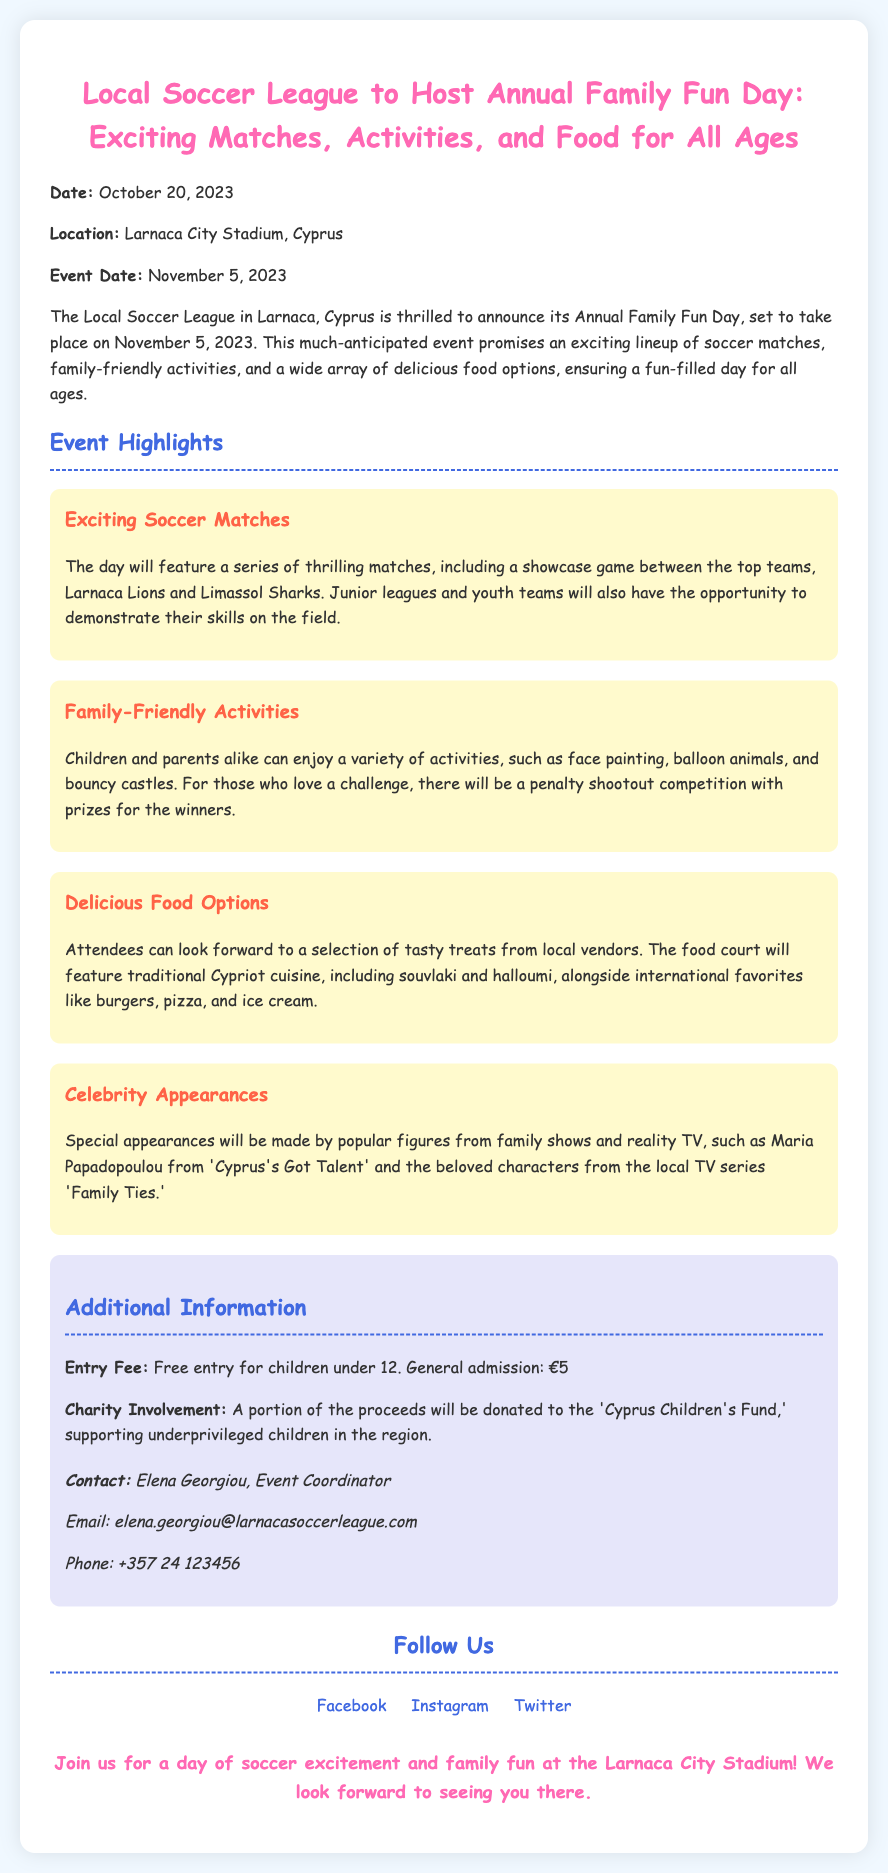What is the date of the event? The event is scheduled for November 5, 2023, as mentioned in the document.
Answer: November 5, 2023 Where is the Family Fun Day taking place? The location specified for the event is Larnaca City Stadium, Cyprus.
Answer: Larnaca City Stadium, Cyprus Who are the two top teams playing in the showcase game? The document highlights the match between Larnaca Lions and Limassol Sharks as part of the event.
Answer: Larnaca Lions and Limassol Sharks What age group has free entry to the event? It states that children under 12 can enter the event for free.
Answer: Children under 12 Which charity will benefit from the event proceeds? The document mentions that a portion of the proceeds will go to the 'Cyprus Children's Fund.'
Answer: Cyprus Children's Fund What type of food can attendees expect? The document lists traditional Cypriot cuisine, which includes souvlaki and halloumi, among other food options.
Answer: Souvlaki and halloumi Who is the contact person for the event? Elena Georgiou is noted as the Event Coordinator for the Family Fun Day.
Answer: Elena Georgiou What special appearances are mentioned in the press release? The document mentions appearances by Maria Papadopoulou and characters from 'Family Ties.'
Answer: Maria Papadopoulou and characters from 'Family Ties' 